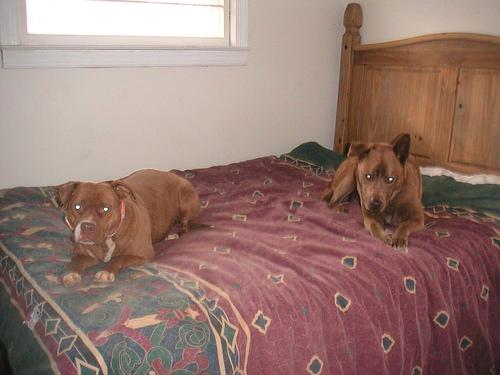Should the dogs be on the bed?
Write a very short answer. No. How many dogs are here?
Concise answer only. 2. Are the dogs asleep?
Short answer required. No. 